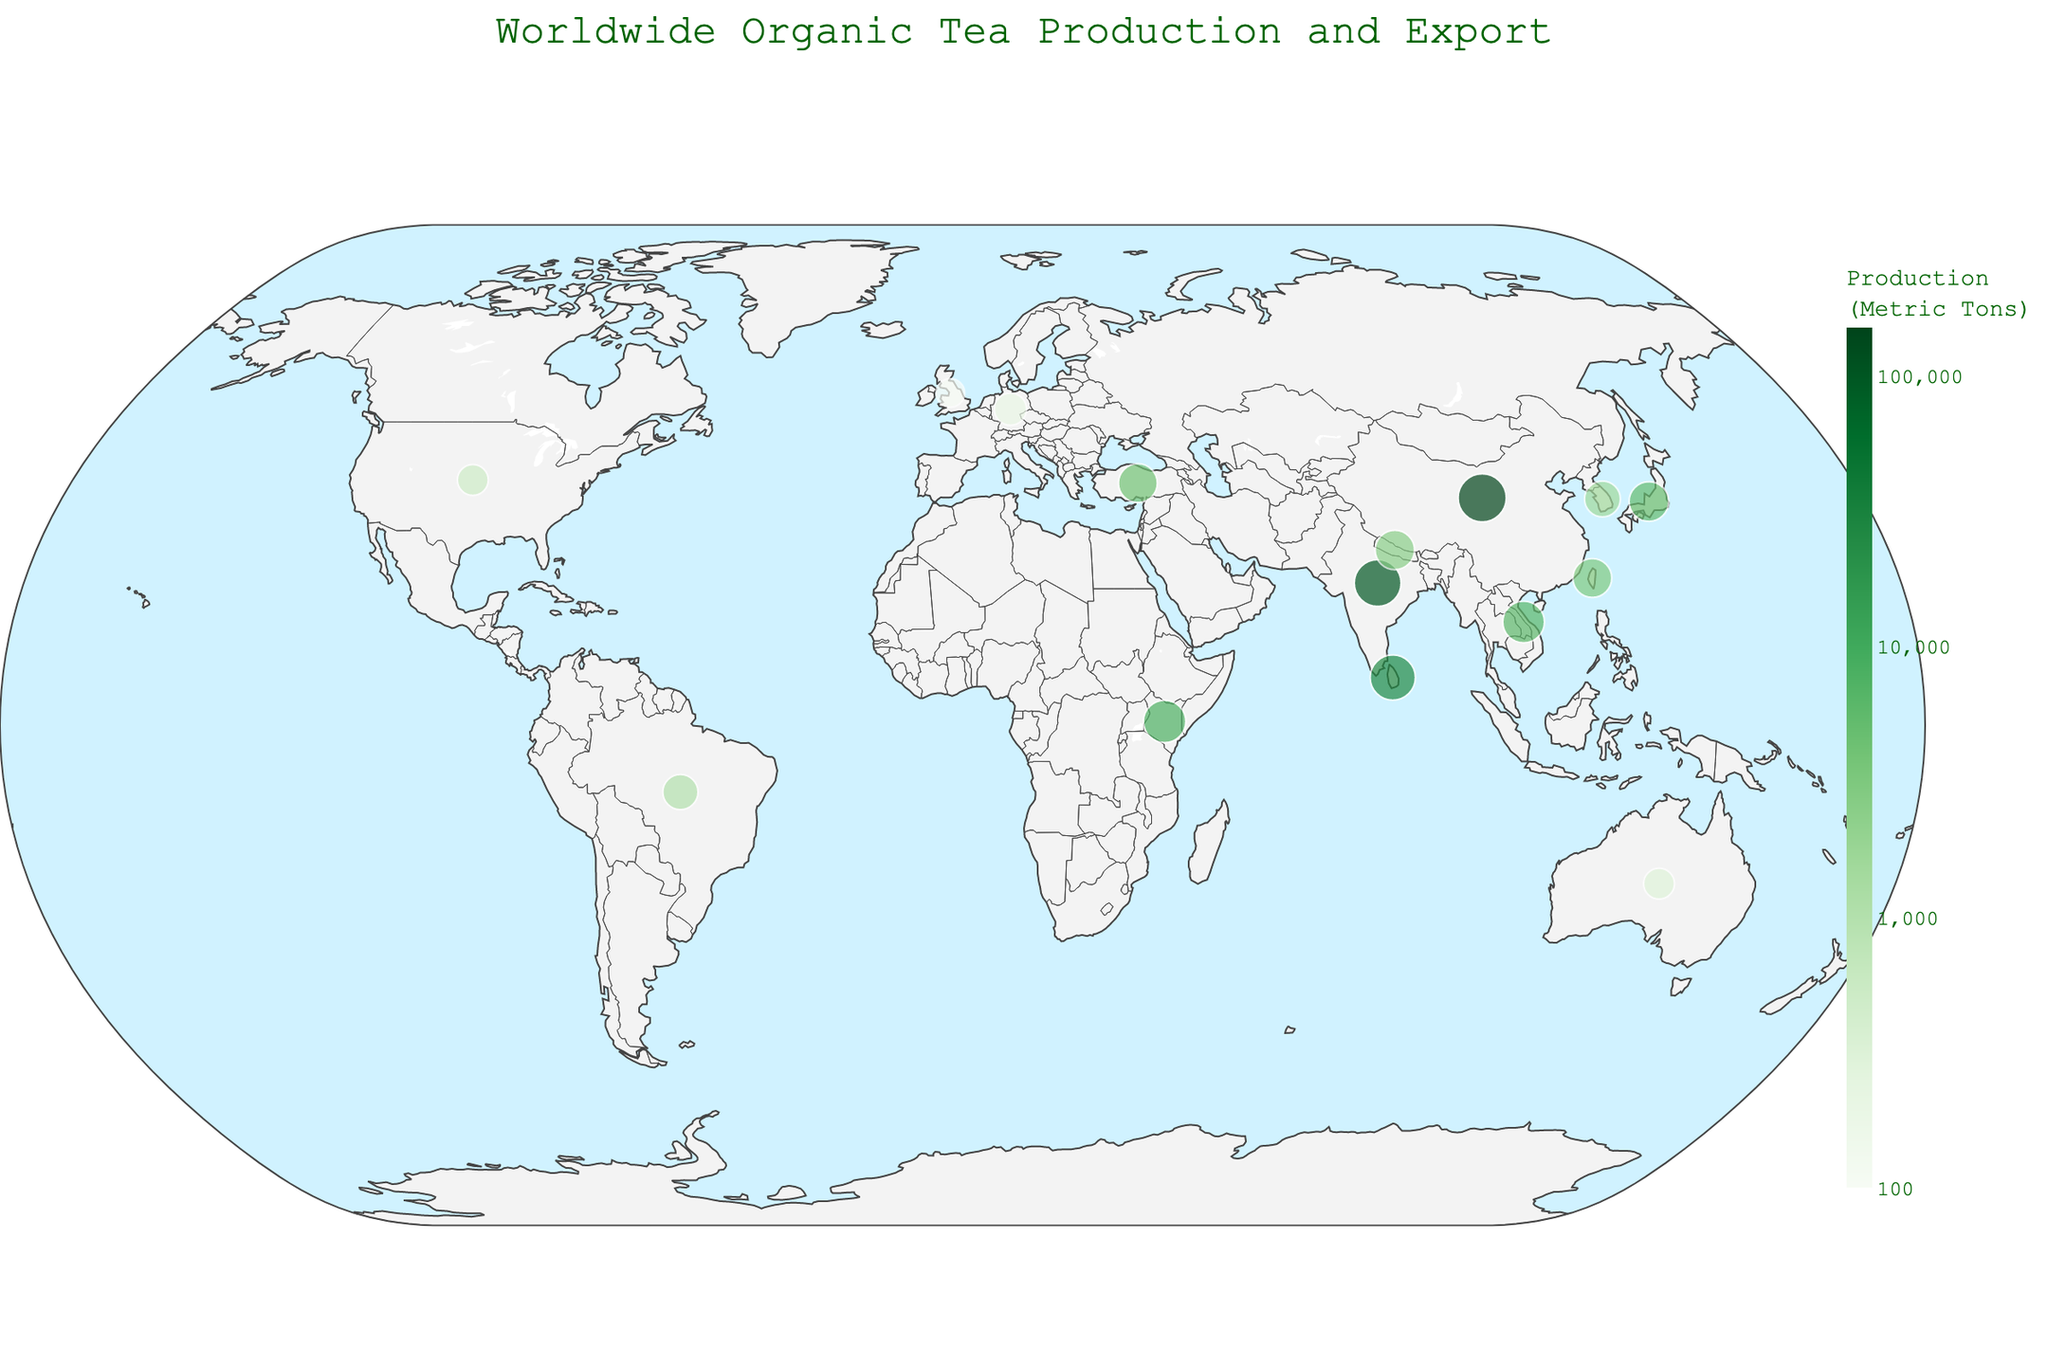How many countries are represented in this plot? Count the unique countries on the visual plot.
Answer: 15 Which country has the highest log scale of Organic Tea Production? Look for the country with the darkest shade of green which indicates the highest value on the log scale.
Answer: China Which country has the smallest bubble size for Organic Tea Export Volume? Look for the country with the smallest circle size on the plot which represents the export volume on a log scale.
Answer: United Kingdom What is the log scale color range for Organic Tea Production on this plot? Check the color bar on the right side of the plot which shows the log scale values. The range is marked using different shades of green.
Answer: 2 to 5 Compare the Organic Tea Export Volumes of India and Kenya. Which one is larger? Look at the size of the bubbles for India and Kenya. India's bubble is smaller than Kenya's, indicating lower export volume.
Answer: Kenya What is the title of the plot? The title is usually situated at the top of the plot and it helps to describe what the plot is about.
Answer: Worldwide Organic Tea Production and Export Find a country with similar Organic Tea Export Volumes but significantly different Production Volumes. Examine bubbles of similar sizes (indicating export volume) but different colors (indicating production volume). For example, compare Nepal (light green) and Turkey (darker shade).
Answer: Nepal and Turkey Which country has a higher Organic Tea Export Volume: Sri Lanka or Vietnam? Compare the bubble sizes for Sri Lanka and Vietnam on the plot, Vietnam's bubble is slightly larger.
Answer: Vietnam How does the Organic Tea Production of Japan compare to that of Taiwan? Look at the colors of Japan and Taiwan. Japan's shade of green indicates a lower production in comparison to Taiwan.
Answer: Taiwan is higher Among the countries with the lowest production volumes, which one has the highest export volume? Examine countries with the lightest green bubbles to identify the smallest production volumes, then among them, find the one with the largest bubble size for highest export volumes.
Answer: Nepal 